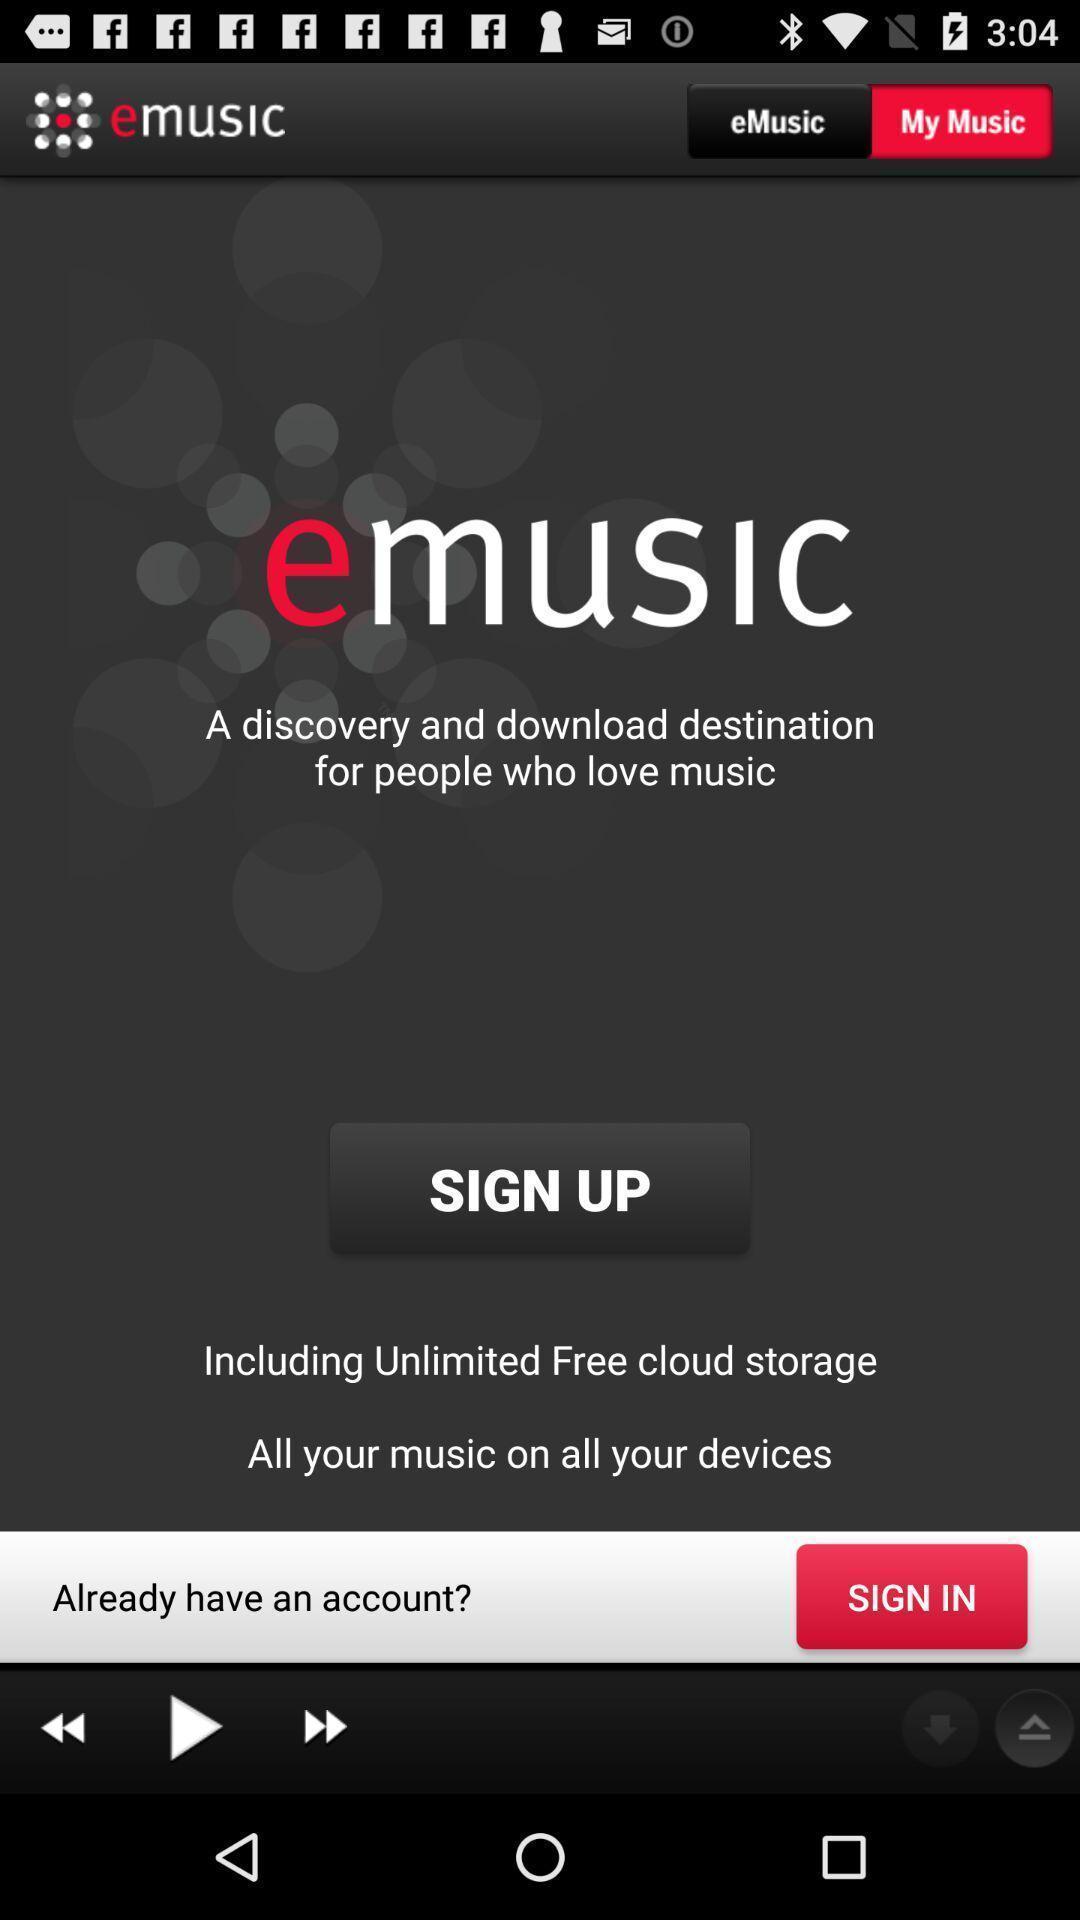Give me a narrative description of this picture. Sign up page for a music application. 